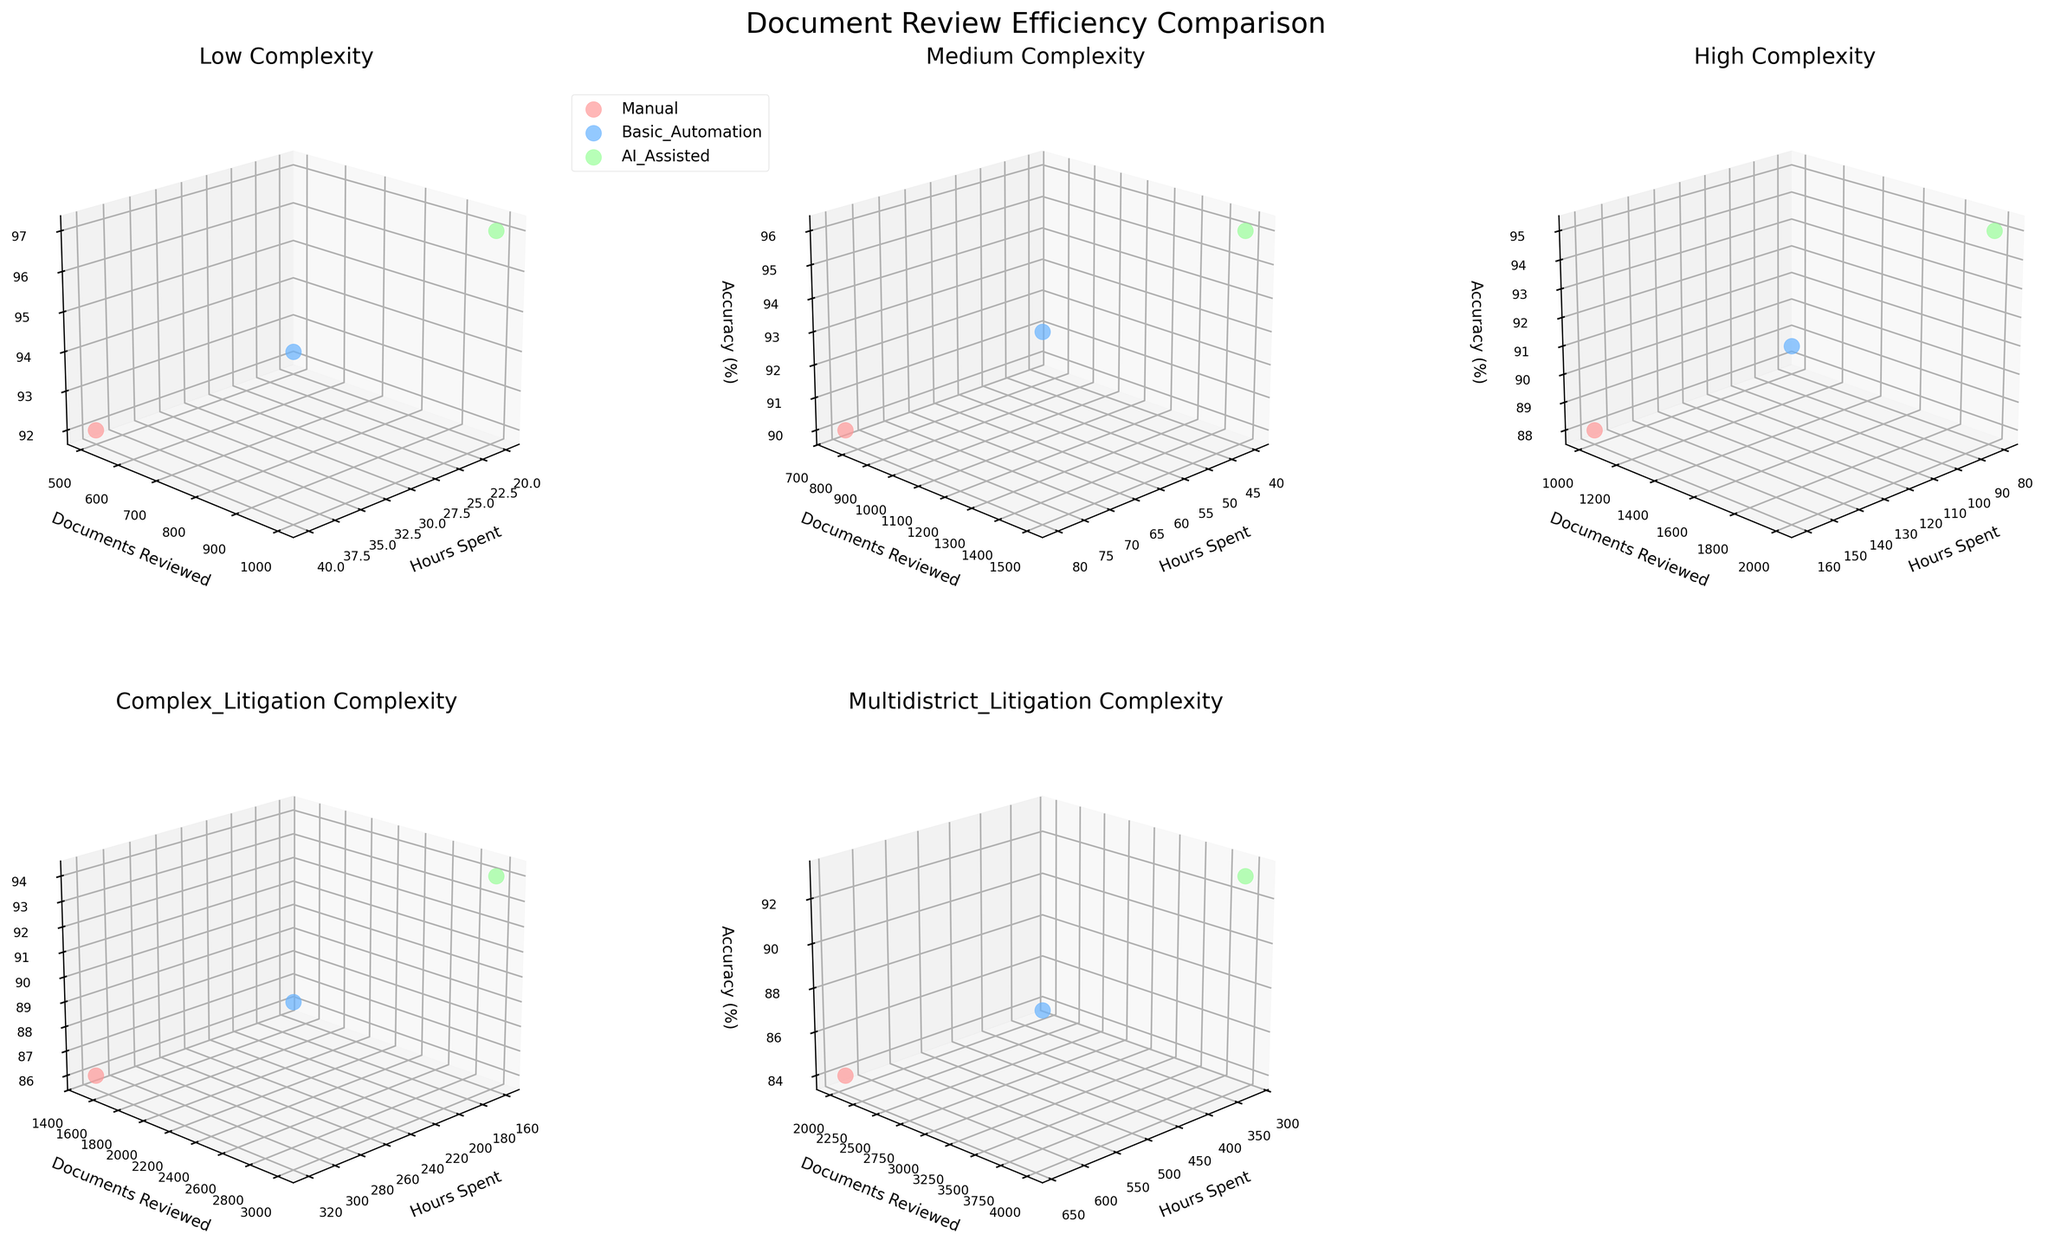How many review methods are compared in the plot? The legend on the plot, located in the upper left corner, shows three distinct methods: Manual, Basic Automation, and AI-Assisted methods.
Answer: Three What's the title of the plot? The title of the plot, centered at the top of the figure, reads "Document Review Efficiency Comparison."
Answer: Document Review Efficiency Comparison For the 'Low' complexity case, which review method spends the least hours? In the subplot for 'Low' complexity cases, observe the 'Hours Spent' axis and compare the positions of the three methods. 'AI-Assisted' methods show the least hours spent.
Answer: AI-Assisted Comparing 'Manual' and 'Basic Automation' methods for 'High' complexity cases, which one reviews more documents? Look at the 'High' complexity subplot for the dots representing 'Manual' and 'Basic Automation'. The 'Basic Automation' dot is further along the 'Documents Reviewed' axis.
Answer: Basic Automation What is the accuracy percentage for 'AI-Assisted' review in 'Complex Litigation' cases? In the 'Complex Litigation' case subplot, find the marker for 'AI-Assisted' methods and look at its position on the 'Accuracy (%)' axis.
Answer: 94% Which subplot has the highest hours spent for 'Manual' review? Examine all subplots and compare the highest values on the 'Hours Spent' axis for the 'Manual' review markers. The 'Multidistrict Litigation' subplot has the highest hours spent.
Answer: Multidistrict Litigation For 'Medium' complexity cases, what is the difference in accuracy percentage between 'Manual' and 'AI-Assisted' reviews? In the 'Medium' complexity subplot, the accuracy percentage for 'Manual' is 90% and for 'AI-Assisted' is 96%. The difference is 96% - 90%.
Answer: 6% In 'Complex Litigation' cases, which review method balances high accuracy with the least hours spent? In the 'Complex Litigation' subplot, compare each method for the least hours spent and the highest accuracy. 'AI-Assisted' methods show both high accuracy (94%) and relatively low hours (160).
Answer: AI-Assisted How does 'Basic Automation' methods perform in terms of accuracy for 'Low' and 'High' complexity cases? Looking at subplots for 'Low' and 'High' complexities, 'Basic Automation' methods show an accuracy of 94% for 'Low' complexity and 91% for 'High' complexity.
Answer: 94% for Low, 91% for High 